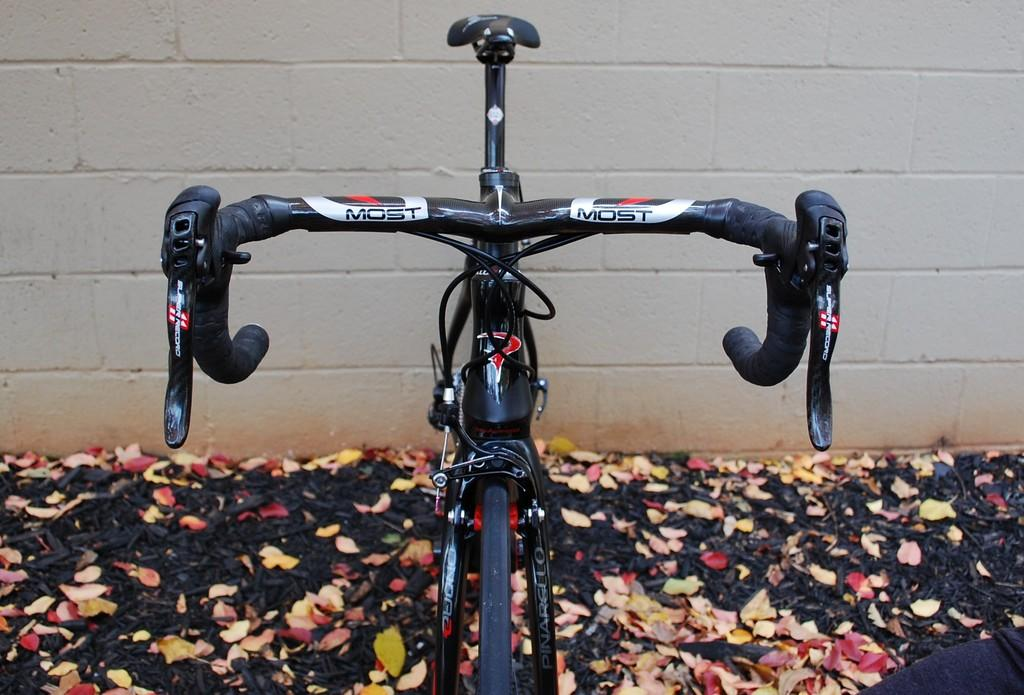What type of vehicle is in the image? There is a bicycle with stickers in the image. What can be seen at the bottom of the image? Leaves are visible at the bottom of the image. What is in the background of the image? There is a wall in the background of the image. How many screws can be seen on the bicycle in the image? There is no mention of screws on the bicycle in the image, so it is not possible to determine the number of screws. 